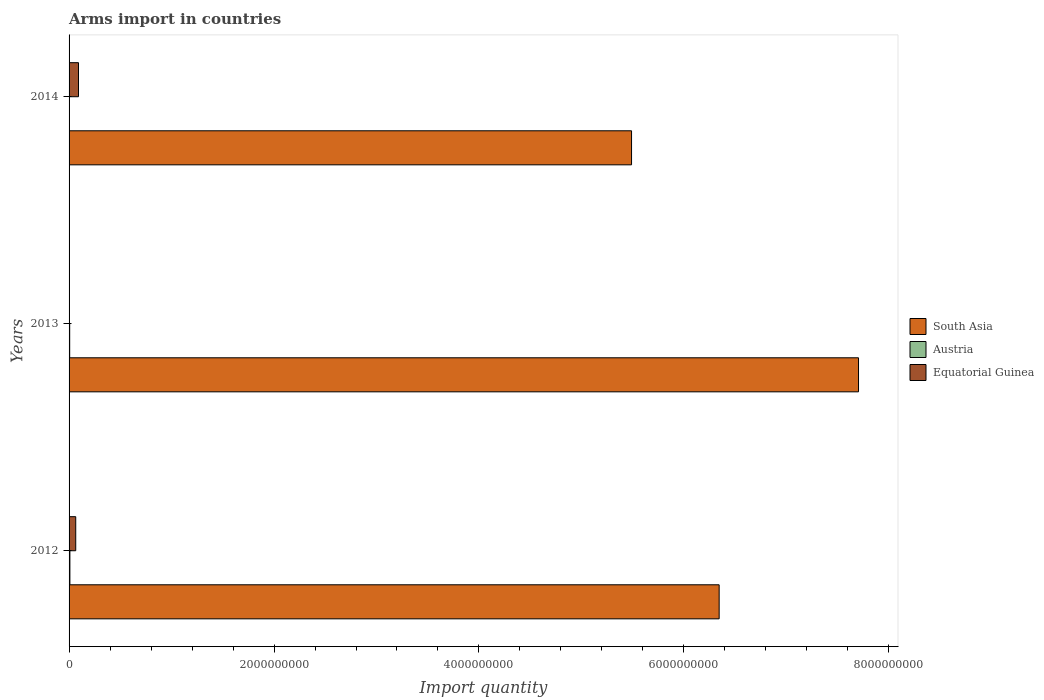How many different coloured bars are there?
Your response must be concise. 3. Are the number of bars per tick equal to the number of legend labels?
Ensure brevity in your answer.  Yes. Are the number of bars on each tick of the Y-axis equal?
Your answer should be very brief. Yes. How many bars are there on the 3rd tick from the bottom?
Make the answer very short. 3. What is the label of the 3rd group of bars from the top?
Offer a terse response. 2012. In how many cases, is the number of bars for a given year not equal to the number of legend labels?
Make the answer very short. 0. What is the total arms import in Austria in 2012?
Offer a terse response. 8.00e+06. Across all years, what is the maximum total arms import in Equatorial Guinea?
Your answer should be compact. 9.20e+07. Across all years, what is the minimum total arms import in Austria?
Your answer should be compact. 2.00e+06. In which year was the total arms import in Equatorial Guinea maximum?
Offer a terse response. 2014. In which year was the total arms import in South Asia minimum?
Offer a very short reply. 2014. What is the total total arms import in Equatorial Guinea in the graph?
Provide a short and direct response. 1.59e+08. What is the difference between the total arms import in Austria in 2013 and that in 2014?
Your response must be concise. 4.00e+06. What is the difference between the total arms import in Equatorial Guinea in 2014 and the total arms import in South Asia in 2012?
Your response must be concise. -6.25e+09. What is the average total arms import in Austria per year?
Your response must be concise. 5.33e+06. In the year 2013, what is the difference between the total arms import in Equatorial Guinea and total arms import in South Asia?
Keep it short and to the point. -7.70e+09. What is the ratio of the total arms import in Equatorial Guinea in 2013 to that in 2014?
Your response must be concise. 0.02. What is the difference between the highest and the second highest total arms import in South Asia?
Make the answer very short. 1.36e+09. What is the difference between the highest and the lowest total arms import in Equatorial Guinea?
Offer a terse response. 9.00e+07. Is it the case that in every year, the sum of the total arms import in Equatorial Guinea and total arms import in Austria is greater than the total arms import in South Asia?
Ensure brevity in your answer.  No. Are all the bars in the graph horizontal?
Provide a short and direct response. Yes. Does the graph contain any zero values?
Offer a terse response. No. Does the graph contain grids?
Make the answer very short. No. Where does the legend appear in the graph?
Your response must be concise. Center right. How many legend labels are there?
Offer a terse response. 3. How are the legend labels stacked?
Your response must be concise. Vertical. What is the title of the graph?
Provide a succinct answer. Arms import in countries. Does "Nepal" appear as one of the legend labels in the graph?
Provide a succinct answer. No. What is the label or title of the X-axis?
Keep it short and to the point. Import quantity. What is the label or title of the Y-axis?
Your answer should be compact. Years. What is the Import quantity of South Asia in 2012?
Keep it short and to the point. 6.34e+09. What is the Import quantity in Equatorial Guinea in 2012?
Give a very brief answer. 6.50e+07. What is the Import quantity of South Asia in 2013?
Your answer should be compact. 7.70e+09. What is the Import quantity in Austria in 2013?
Your answer should be compact. 6.00e+06. What is the Import quantity in Equatorial Guinea in 2013?
Your answer should be compact. 2.00e+06. What is the Import quantity of South Asia in 2014?
Keep it short and to the point. 5.49e+09. What is the Import quantity of Equatorial Guinea in 2014?
Give a very brief answer. 9.20e+07. Across all years, what is the maximum Import quantity in South Asia?
Provide a succinct answer. 7.70e+09. Across all years, what is the maximum Import quantity in Austria?
Your answer should be compact. 8.00e+06. Across all years, what is the maximum Import quantity in Equatorial Guinea?
Provide a short and direct response. 9.20e+07. Across all years, what is the minimum Import quantity in South Asia?
Make the answer very short. 5.49e+09. What is the total Import quantity of South Asia in the graph?
Your answer should be very brief. 1.95e+1. What is the total Import quantity of Austria in the graph?
Your response must be concise. 1.60e+07. What is the total Import quantity in Equatorial Guinea in the graph?
Your answer should be very brief. 1.59e+08. What is the difference between the Import quantity in South Asia in 2012 and that in 2013?
Give a very brief answer. -1.36e+09. What is the difference between the Import quantity in Equatorial Guinea in 2012 and that in 2013?
Your response must be concise. 6.30e+07. What is the difference between the Import quantity of South Asia in 2012 and that in 2014?
Make the answer very short. 8.55e+08. What is the difference between the Import quantity in Equatorial Guinea in 2012 and that in 2014?
Keep it short and to the point. -2.70e+07. What is the difference between the Import quantity of South Asia in 2013 and that in 2014?
Offer a very short reply. 2.22e+09. What is the difference between the Import quantity of Equatorial Guinea in 2013 and that in 2014?
Give a very brief answer. -9.00e+07. What is the difference between the Import quantity in South Asia in 2012 and the Import quantity in Austria in 2013?
Keep it short and to the point. 6.34e+09. What is the difference between the Import quantity of South Asia in 2012 and the Import quantity of Equatorial Guinea in 2013?
Provide a succinct answer. 6.34e+09. What is the difference between the Import quantity of Austria in 2012 and the Import quantity of Equatorial Guinea in 2013?
Offer a very short reply. 6.00e+06. What is the difference between the Import quantity in South Asia in 2012 and the Import quantity in Austria in 2014?
Your response must be concise. 6.34e+09. What is the difference between the Import quantity of South Asia in 2012 and the Import quantity of Equatorial Guinea in 2014?
Provide a short and direct response. 6.25e+09. What is the difference between the Import quantity in Austria in 2012 and the Import quantity in Equatorial Guinea in 2014?
Your answer should be compact. -8.40e+07. What is the difference between the Import quantity in South Asia in 2013 and the Import quantity in Austria in 2014?
Ensure brevity in your answer.  7.70e+09. What is the difference between the Import quantity in South Asia in 2013 and the Import quantity in Equatorial Guinea in 2014?
Ensure brevity in your answer.  7.61e+09. What is the difference between the Import quantity in Austria in 2013 and the Import quantity in Equatorial Guinea in 2014?
Your answer should be compact. -8.60e+07. What is the average Import quantity in South Asia per year?
Offer a terse response. 6.51e+09. What is the average Import quantity of Austria per year?
Make the answer very short. 5.33e+06. What is the average Import quantity in Equatorial Guinea per year?
Give a very brief answer. 5.30e+07. In the year 2012, what is the difference between the Import quantity of South Asia and Import quantity of Austria?
Offer a very short reply. 6.34e+09. In the year 2012, what is the difference between the Import quantity of South Asia and Import quantity of Equatorial Guinea?
Give a very brief answer. 6.28e+09. In the year 2012, what is the difference between the Import quantity in Austria and Import quantity in Equatorial Guinea?
Provide a short and direct response. -5.70e+07. In the year 2013, what is the difference between the Import quantity of South Asia and Import quantity of Austria?
Provide a succinct answer. 7.70e+09. In the year 2013, what is the difference between the Import quantity of South Asia and Import quantity of Equatorial Guinea?
Ensure brevity in your answer.  7.70e+09. In the year 2014, what is the difference between the Import quantity of South Asia and Import quantity of Austria?
Provide a succinct answer. 5.49e+09. In the year 2014, what is the difference between the Import quantity in South Asia and Import quantity in Equatorial Guinea?
Provide a succinct answer. 5.40e+09. In the year 2014, what is the difference between the Import quantity of Austria and Import quantity of Equatorial Guinea?
Offer a terse response. -9.00e+07. What is the ratio of the Import quantity of South Asia in 2012 to that in 2013?
Provide a succinct answer. 0.82. What is the ratio of the Import quantity in Austria in 2012 to that in 2013?
Your answer should be compact. 1.33. What is the ratio of the Import quantity of Equatorial Guinea in 2012 to that in 2013?
Provide a succinct answer. 32.5. What is the ratio of the Import quantity of South Asia in 2012 to that in 2014?
Ensure brevity in your answer.  1.16. What is the ratio of the Import quantity of Austria in 2012 to that in 2014?
Provide a short and direct response. 4. What is the ratio of the Import quantity in Equatorial Guinea in 2012 to that in 2014?
Keep it short and to the point. 0.71. What is the ratio of the Import quantity of South Asia in 2013 to that in 2014?
Provide a succinct answer. 1.4. What is the ratio of the Import quantity in Austria in 2013 to that in 2014?
Ensure brevity in your answer.  3. What is the ratio of the Import quantity of Equatorial Guinea in 2013 to that in 2014?
Ensure brevity in your answer.  0.02. What is the difference between the highest and the second highest Import quantity of South Asia?
Keep it short and to the point. 1.36e+09. What is the difference between the highest and the second highest Import quantity of Equatorial Guinea?
Keep it short and to the point. 2.70e+07. What is the difference between the highest and the lowest Import quantity of South Asia?
Offer a terse response. 2.22e+09. What is the difference between the highest and the lowest Import quantity in Equatorial Guinea?
Provide a succinct answer. 9.00e+07. 